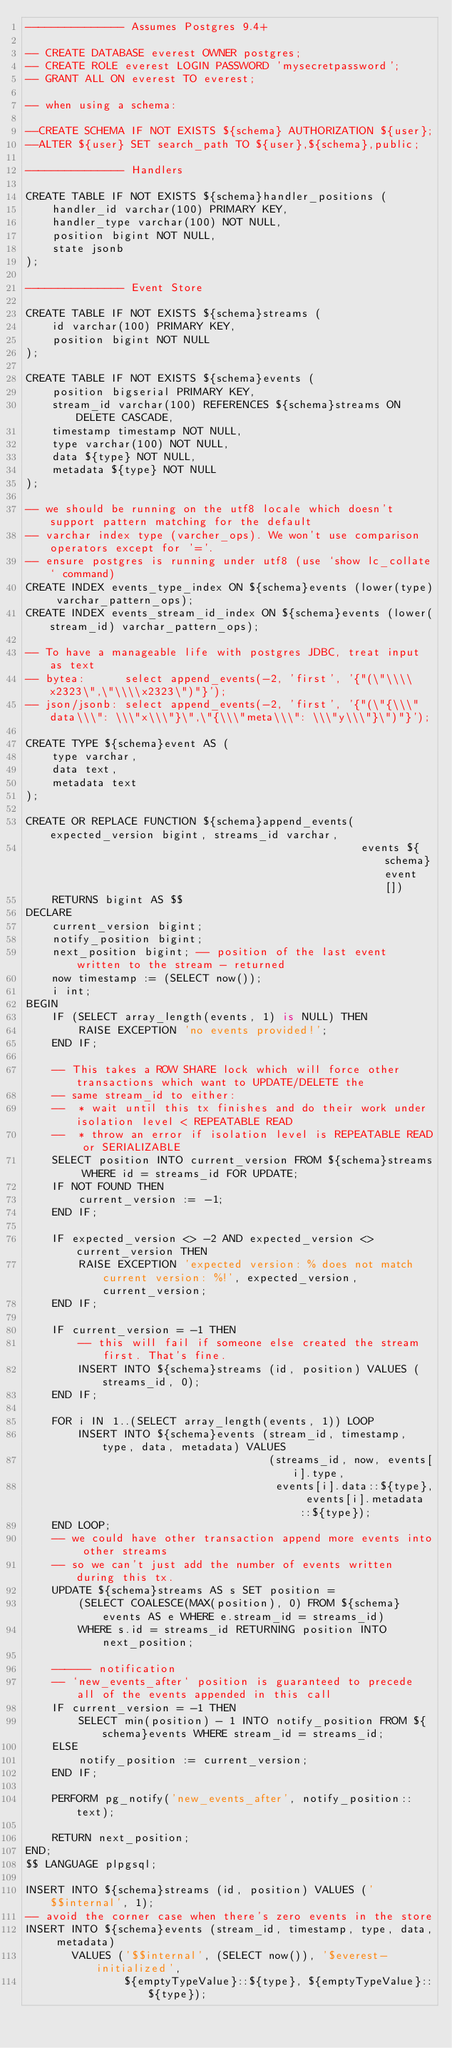<code> <loc_0><loc_0><loc_500><loc_500><_SQL_>--------------- Assumes Postgres 9.4+

-- CREATE DATABASE everest OWNER postgres;
-- CREATE ROLE everest LOGIN PASSWORD 'mysecretpassword';
-- GRANT ALL ON everest TO everest;

-- when using a schema:

--CREATE SCHEMA IF NOT EXISTS ${schema} AUTHORIZATION ${user};
--ALTER ${user} SET search_path TO ${user},${schema},public;

--------------- Handlers

CREATE TABLE IF NOT EXISTS ${schema}handler_positions (
    handler_id varchar(100) PRIMARY KEY,
    handler_type varchar(100) NOT NULL,
    position bigint NOT NULL,
    state jsonb
);

--------------- Event Store

CREATE TABLE IF NOT EXISTS ${schema}streams (
    id varchar(100) PRIMARY KEY,
    position bigint NOT NULL
);

CREATE TABLE IF NOT EXISTS ${schema}events (
    position bigserial PRIMARY KEY,
    stream_id varchar(100) REFERENCES ${schema}streams ON DELETE CASCADE,
    timestamp timestamp NOT NULL,
    type varchar(100) NOT NULL,
    data ${type} NOT NULL,
    metadata ${type} NOT NULL
);

-- we should be running on the utf8 locale which doesn't support pattern matching for the default
-- varchar index type (varcher_ops). We won't use comparison operators except for '='.
-- ensure postgres is running under utf8 (use `show lc_collate` command)
CREATE INDEX events_type_index ON ${schema}events (lower(type) varchar_pattern_ops);
CREATE INDEX events_stream_id_index ON ${schema}events (lower(stream_id) varchar_pattern_ops);

-- To have a manageable life with postgres JDBC, treat input as text
-- bytea:      select append_events(-2, 'first', '{"(\"\\\\x2323\",\"\\\\x2323\")"}');
-- json/jsonb: select append_events(-2, 'first', '{"(\"{\\\"data\\\": \\\"x\\\"}\",\"{\\\"meta\\\": \\\"y\\\"}\")"}');

CREATE TYPE ${schema}event AS (
    type varchar,
    data text,
    metadata text
);

CREATE OR REPLACE FUNCTION ${schema}append_events(expected_version bigint, streams_id varchar,
                                                   events ${schema}event[])
    RETURNS bigint AS $$
DECLARE
    current_version bigint;
    notify_position bigint;
    next_position bigint; -- position of the last event written to the stream - returned
    now timestamp := (SELECT now());
    i int;
BEGIN
    IF (SELECT array_length(events, 1) is NULL) THEN
        RAISE EXCEPTION 'no events provided!';
    END IF;

    -- This takes a ROW SHARE lock which will force other transactions which want to UPDATE/DELETE the
    -- same stream_id to either:
    --  * wait until this tx finishes and do their work under isolation level < REPEATABLE READ
    --  * throw an error if isolation level is REPEATABLE READ or SERIALIZABLE
    SELECT position INTO current_version FROM ${schema}streams WHERE id = streams_id FOR UPDATE;
    IF NOT FOUND THEN
        current_version := -1;
    END IF;

    IF expected_version <> -2 AND expected_version <> current_version THEN
        RAISE EXCEPTION 'expected version: % does not match current version: %!', expected_version, current_version;
    END IF;

    IF current_version = -1 THEN
        -- this will fail if someone else created the stream first. That's fine.
        INSERT INTO ${schema}streams (id, position) VALUES (streams_id, 0);
    END IF;

    FOR i IN 1..(SELECT array_length(events, 1)) LOOP
        INSERT INTO ${schema}events (stream_id, timestamp, type, data, metadata) VALUES
                                     (streams_id, now, events[i].type,
                                      events[i].data::${type}, events[i].metadata::${type});
    END LOOP;
    -- we could have other transaction append more events into other streams
    -- so we can't just add the number of events written during this tx.
    UPDATE ${schema}streams AS s SET position =
        (SELECT COALESCE(MAX(position), 0) FROM ${schema}events AS e WHERE e.stream_id = streams_id)
        WHERE s.id = streams_id RETURNING position INTO next_position;

    ------ notification
    -- `new_events_after` position is guaranteed to precede all of the events appended in this call
    IF current_version = -1 THEN
        SELECT min(position) - 1 INTO notify_position FROM ${schema}events WHERE stream_id = streams_id;
    ELSE
        notify_position := current_version;
    END IF;

    PERFORM pg_notify('new_events_after', notify_position::text);

    RETURN next_position;
END;
$$ LANGUAGE plpgsql;

INSERT INTO ${schema}streams (id, position) VALUES ('$$internal', 1);
-- avoid the corner case when there's zero events in the store
INSERT INTO ${schema}events (stream_id, timestamp, type, data, metadata)
       VALUES ('$$internal', (SELECT now()), '$everest-initialized',
               ${emptyTypeValue}::${type}, ${emptyTypeValue}::${type});
</code> 